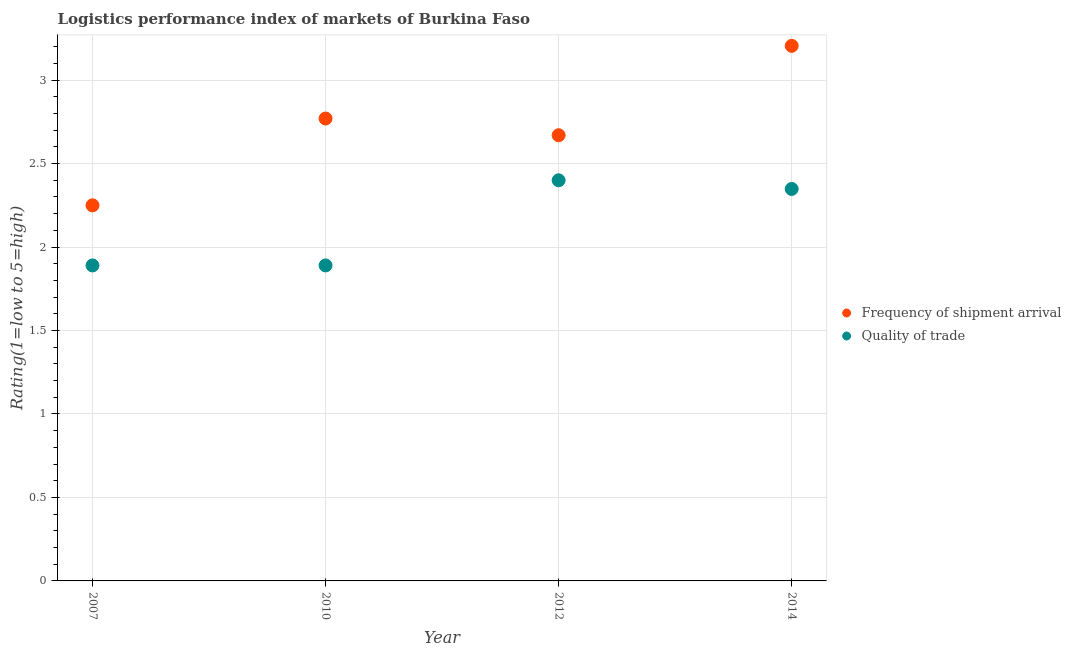Is the number of dotlines equal to the number of legend labels?
Provide a short and direct response. Yes. What is the lpi of frequency of shipment arrival in 2007?
Offer a terse response. 2.25. Across all years, what is the maximum lpi of frequency of shipment arrival?
Provide a short and direct response. 3.21. Across all years, what is the minimum lpi of frequency of shipment arrival?
Provide a short and direct response. 2.25. In which year was the lpi quality of trade maximum?
Offer a terse response. 2012. In which year was the lpi of frequency of shipment arrival minimum?
Your answer should be compact. 2007. What is the total lpi quality of trade in the graph?
Give a very brief answer. 8.53. What is the difference between the lpi of frequency of shipment arrival in 2007 and that in 2012?
Ensure brevity in your answer.  -0.42. What is the difference between the lpi of frequency of shipment arrival in 2010 and the lpi quality of trade in 2014?
Your answer should be compact. 0.42. What is the average lpi of frequency of shipment arrival per year?
Provide a short and direct response. 2.72. In the year 2014, what is the difference between the lpi quality of trade and lpi of frequency of shipment arrival?
Make the answer very short. -0.86. What is the ratio of the lpi of frequency of shipment arrival in 2007 to that in 2012?
Ensure brevity in your answer.  0.84. Is the lpi of frequency of shipment arrival in 2010 less than that in 2012?
Offer a very short reply. No. What is the difference between the highest and the second highest lpi quality of trade?
Provide a succinct answer. 0.05. What is the difference between the highest and the lowest lpi of frequency of shipment arrival?
Provide a short and direct response. 0.96. In how many years, is the lpi quality of trade greater than the average lpi quality of trade taken over all years?
Your answer should be compact. 2. How many years are there in the graph?
Ensure brevity in your answer.  4. What is the difference between two consecutive major ticks on the Y-axis?
Your response must be concise. 0.5. Are the values on the major ticks of Y-axis written in scientific E-notation?
Your response must be concise. No. Does the graph contain any zero values?
Your response must be concise. No. Does the graph contain grids?
Provide a succinct answer. Yes. How many legend labels are there?
Give a very brief answer. 2. How are the legend labels stacked?
Give a very brief answer. Vertical. What is the title of the graph?
Ensure brevity in your answer.  Logistics performance index of markets of Burkina Faso. Does "Canada" appear as one of the legend labels in the graph?
Ensure brevity in your answer.  No. What is the label or title of the Y-axis?
Offer a terse response. Rating(1=low to 5=high). What is the Rating(1=low to 5=high) of Frequency of shipment arrival in 2007?
Offer a terse response. 2.25. What is the Rating(1=low to 5=high) of Quality of trade in 2007?
Offer a terse response. 1.89. What is the Rating(1=low to 5=high) in Frequency of shipment arrival in 2010?
Give a very brief answer. 2.77. What is the Rating(1=low to 5=high) in Quality of trade in 2010?
Offer a very short reply. 1.89. What is the Rating(1=low to 5=high) of Frequency of shipment arrival in 2012?
Your answer should be compact. 2.67. What is the Rating(1=low to 5=high) of Quality of trade in 2012?
Provide a succinct answer. 2.4. What is the Rating(1=low to 5=high) in Frequency of shipment arrival in 2014?
Keep it short and to the point. 3.21. What is the Rating(1=low to 5=high) in Quality of trade in 2014?
Offer a very short reply. 2.35. Across all years, what is the maximum Rating(1=low to 5=high) in Frequency of shipment arrival?
Your response must be concise. 3.21. Across all years, what is the maximum Rating(1=low to 5=high) in Quality of trade?
Your answer should be very brief. 2.4. Across all years, what is the minimum Rating(1=low to 5=high) of Frequency of shipment arrival?
Ensure brevity in your answer.  2.25. Across all years, what is the minimum Rating(1=low to 5=high) in Quality of trade?
Your answer should be compact. 1.89. What is the total Rating(1=low to 5=high) of Frequency of shipment arrival in the graph?
Provide a succinct answer. 10.9. What is the total Rating(1=low to 5=high) of Quality of trade in the graph?
Provide a succinct answer. 8.53. What is the difference between the Rating(1=low to 5=high) of Frequency of shipment arrival in 2007 and that in 2010?
Give a very brief answer. -0.52. What is the difference between the Rating(1=low to 5=high) in Frequency of shipment arrival in 2007 and that in 2012?
Offer a terse response. -0.42. What is the difference between the Rating(1=low to 5=high) in Quality of trade in 2007 and that in 2012?
Keep it short and to the point. -0.51. What is the difference between the Rating(1=low to 5=high) in Frequency of shipment arrival in 2007 and that in 2014?
Make the answer very short. -0.96. What is the difference between the Rating(1=low to 5=high) in Quality of trade in 2007 and that in 2014?
Offer a very short reply. -0.46. What is the difference between the Rating(1=low to 5=high) of Quality of trade in 2010 and that in 2012?
Provide a succinct answer. -0.51. What is the difference between the Rating(1=low to 5=high) in Frequency of shipment arrival in 2010 and that in 2014?
Your response must be concise. -0.44. What is the difference between the Rating(1=low to 5=high) in Quality of trade in 2010 and that in 2014?
Give a very brief answer. -0.46. What is the difference between the Rating(1=low to 5=high) in Frequency of shipment arrival in 2012 and that in 2014?
Your response must be concise. -0.54. What is the difference between the Rating(1=low to 5=high) of Quality of trade in 2012 and that in 2014?
Your answer should be very brief. 0.05. What is the difference between the Rating(1=low to 5=high) in Frequency of shipment arrival in 2007 and the Rating(1=low to 5=high) in Quality of trade in 2010?
Your answer should be very brief. 0.36. What is the difference between the Rating(1=low to 5=high) of Frequency of shipment arrival in 2007 and the Rating(1=low to 5=high) of Quality of trade in 2012?
Your response must be concise. -0.15. What is the difference between the Rating(1=low to 5=high) in Frequency of shipment arrival in 2007 and the Rating(1=low to 5=high) in Quality of trade in 2014?
Offer a very short reply. -0.1. What is the difference between the Rating(1=low to 5=high) in Frequency of shipment arrival in 2010 and the Rating(1=low to 5=high) in Quality of trade in 2012?
Offer a terse response. 0.37. What is the difference between the Rating(1=low to 5=high) in Frequency of shipment arrival in 2010 and the Rating(1=low to 5=high) in Quality of trade in 2014?
Ensure brevity in your answer.  0.42. What is the difference between the Rating(1=low to 5=high) in Frequency of shipment arrival in 2012 and the Rating(1=low to 5=high) in Quality of trade in 2014?
Make the answer very short. 0.32. What is the average Rating(1=low to 5=high) in Frequency of shipment arrival per year?
Your response must be concise. 2.72. What is the average Rating(1=low to 5=high) in Quality of trade per year?
Give a very brief answer. 2.13. In the year 2007, what is the difference between the Rating(1=low to 5=high) in Frequency of shipment arrival and Rating(1=low to 5=high) in Quality of trade?
Give a very brief answer. 0.36. In the year 2010, what is the difference between the Rating(1=low to 5=high) in Frequency of shipment arrival and Rating(1=low to 5=high) in Quality of trade?
Ensure brevity in your answer.  0.88. In the year 2012, what is the difference between the Rating(1=low to 5=high) of Frequency of shipment arrival and Rating(1=low to 5=high) of Quality of trade?
Your answer should be very brief. 0.27. What is the ratio of the Rating(1=low to 5=high) of Frequency of shipment arrival in 2007 to that in 2010?
Offer a very short reply. 0.81. What is the ratio of the Rating(1=low to 5=high) of Quality of trade in 2007 to that in 2010?
Offer a terse response. 1. What is the ratio of the Rating(1=low to 5=high) of Frequency of shipment arrival in 2007 to that in 2012?
Keep it short and to the point. 0.84. What is the ratio of the Rating(1=low to 5=high) of Quality of trade in 2007 to that in 2012?
Your answer should be compact. 0.79. What is the ratio of the Rating(1=low to 5=high) in Frequency of shipment arrival in 2007 to that in 2014?
Offer a terse response. 0.7. What is the ratio of the Rating(1=low to 5=high) in Quality of trade in 2007 to that in 2014?
Provide a succinct answer. 0.8. What is the ratio of the Rating(1=low to 5=high) in Frequency of shipment arrival in 2010 to that in 2012?
Offer a terse response. 1.04. What is the ratio of the Rating(1=low to 5=high) of Quality of trade in 2010 to that in 2012?
Offer a terse response. 0.79. What is the ratio of the Rating(1=low to 5=high) in Frequency of shipment arrival in 2010 to that in 2014?
Ensure brevity in your answer.  0.86. What is the ratio of the Rating(1=low to 5=high) in Quality of trade in 2010 to that in 2014?
Offer a terse response. 0.8. What is the ratio of the Rating(1=low to 5=high) of Frequency of shipment arrival in 2012 to that in 2014?
Your answer should be compact. 0.83. What is the ratio of the Rating(1=low to 5=high) in Quality of trade in 2012 to that in 2014?
Your answer should be very brief. 1.02. What is the difference between the highest and the second highest Rating(1=low to 5=high) of Frequency of shipment arrival?
Ensure brevity in your answer.  0.44. What is the difference between the highest and the second highest Rating(1=low to 5=high) of Quality of trade?
Ensure brevity in your answer.  0.05. What is the difference between the highest and the lowest Rating(1=low to 5=high) in Frequency of shipment arrival?
Offer a terse response. 0.96. What is the difference between the highest and the lowest Rating(1=low to 5=high) in Quality of trade?
Your answer should be compact. 0.51. 